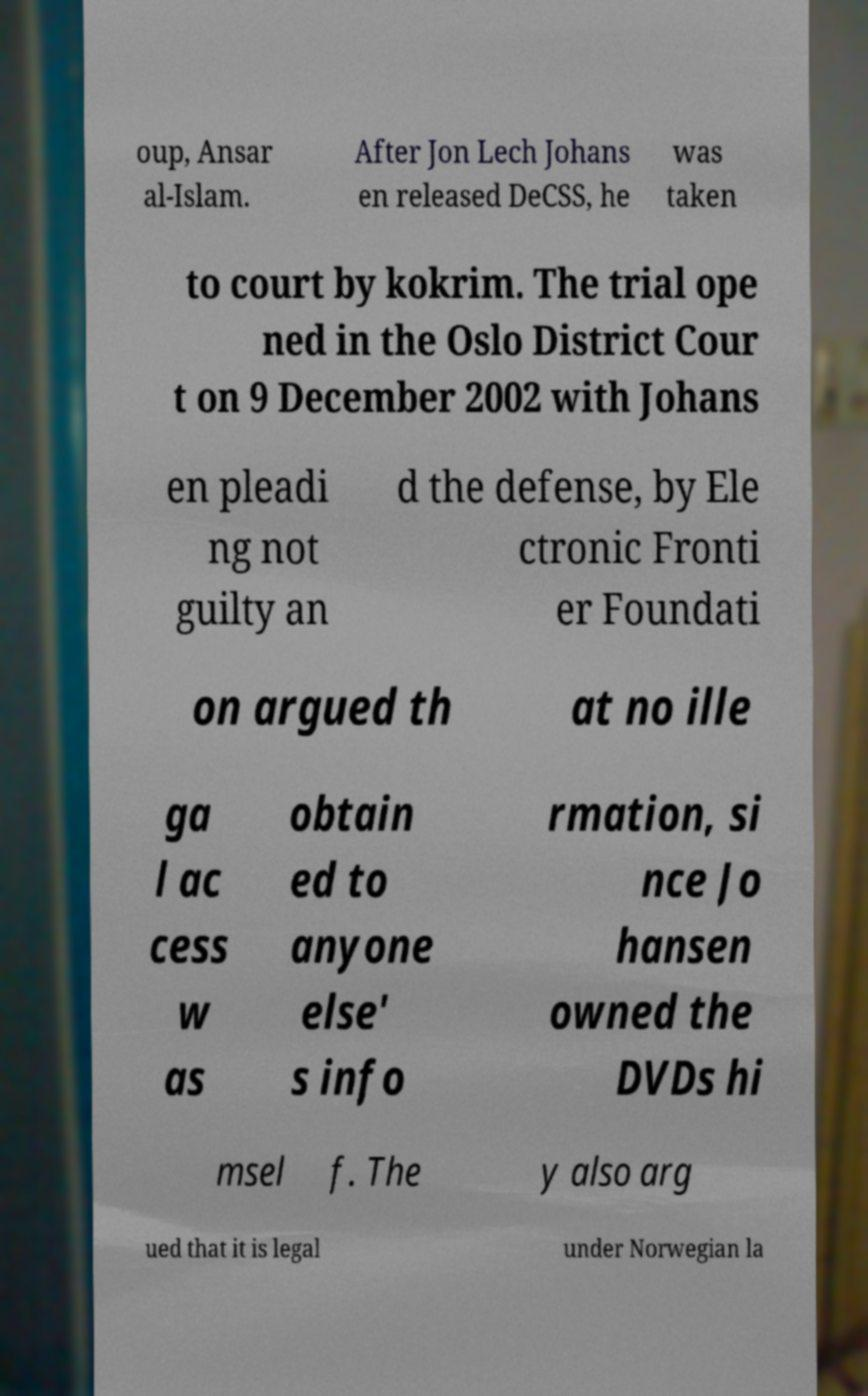For documentation purposes, I need the text within this image transcribed. Could you provide that? oup, Ansar al-Islam. After Jon Lech Johans en released DeCSS, he was taken to court by kokrim. The trial ope ned in the Oslo District Cour t on 9 December 2002 with Johans en pleadi ng not guilty an d the defense, by Ele ctronic Fronti er Foundati on argued th at no ille ga l ac cess w as obtain ed to anyone else' s info rmation, si nce Jo hansen owned the DVDs hi msel f. The y also arg ued that it is legal under Norwegian la 